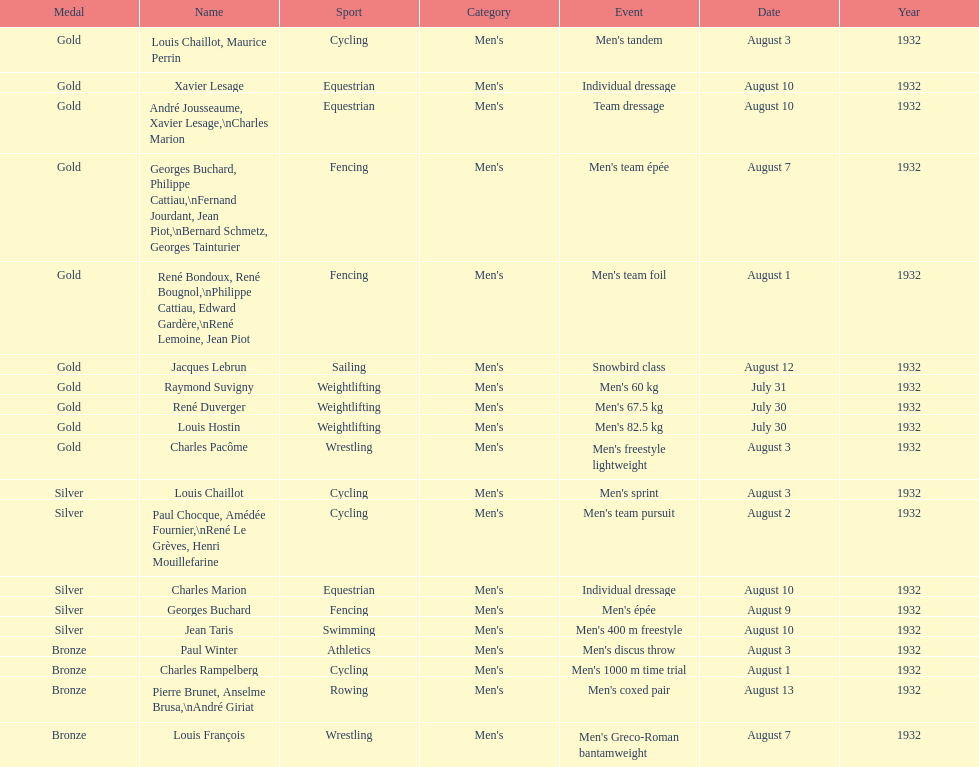How many medals were won after august 3? 9. 